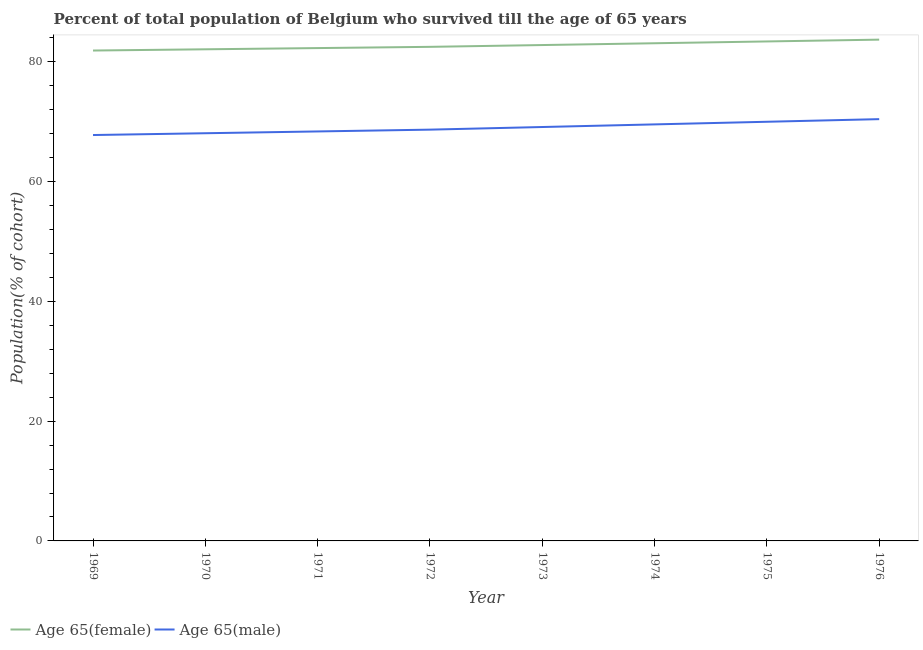How many different coloured lines are there?
Provide a short and direct response. 2. What is the percentage of male population who survived till age of 65 in 1971?
Keep it short and to the point. 68.39. Across all years, what is the maximum percentage of female population who survived till age of 65?
Offer a very short reply. 83.72. Across all years, what is the minimum percentage of male population who survived till age of 65?
Make the answer very short. 67.79. In which year was the percentage of male population who survived till age of 65 maximum?
Your answer should be very brief. 1976. In which year was the percentage of male population who survived till age of 65 minimum?
Offer a terse response. 1969. What is the total percentage of female population who survived till age of 65 in the graph?
Offer a very short reply. 661.88. What is the difference between the percentage of male population who survived till age of 65 in 1969 and that in 1976?
Your answer should be compact. -2.65. What is the difference between the percentage of male population who survived till age of 65 in 1969 and the percentage of female population who survived till age of 65 in 1970?
Your response must be concise. -14.32. What is the average percentage of female population who survived till age of 65 per year?
Provide a succinct answer. 82.74. In the year 1970, what is the difference between the percentage of male population who survived till age of 65 and percentage of female population who survived till age of 65?
Provide a short and direct response. -14.02. What is the ratio of the percentage of female population who survived till age of 65 in 1972 to that in 1974?
Your answer should be compact. 0.99. Is the difference between the percentage of male population who survived till age of 65 in 1969 and 1975 greater than the difference between the percentage of female population who survived till age of 65 in 1969 and 1975?
Ensure brevity in your answer.  No. What is the difference between the highest and the second highest percentage of female population who survived till age of 65?
Provide a succinct answer. 0.3. What is the difference between the highest and the lowest percentage of male population who survived till age of 65?
Provide a succinct answer. 2.65. Is the percentage of female population who survived till age of 65 strictly less than the percentage of male population who survived till age of 65 over the years?
Provide a short and direct response. No. How many years are there in the graph?
Your answer should be very brief. 8. Does the graph contain grids?
Keep it short and to the point. No. Where does the legend appear in the graph?
Offer a very short reply. Bottom left. How many legend labels are there?
Offer a very short reply. 2. What is the title of the graph?
Ensure brevity in your answer.  Percent of total population of Belgium who survived till the age of 65 years. What is the label or title of the Y-axis?
Ensure brevity in your answer.  Population(% of cohort). What is the Population(% of cohort) in Age 65(female) in 1969?
Ensure brevity in your answer.  81.9. What is the Population(% of cohort) of Age 65(male) in 1969?
Provide a succinct answer. 67.79. What is the Population(% of cohort) in Age 65(female) in 1970?
Offer a very short reply. 82.1. What is the Population(% of cohort) in Age 65(male) in 1970?
Your response must be concise. 68.09. What is the Population(% of cohort) in Age 65(female) in 1971?
Give a very brief answer. 82.31. What is the Population(% of cohort) in Age 65(male) in 1971?
Give a very brief answer. 68.39. What is the Population(% of cohort) of Age 65(female) in 1972?
Provide a short and direct response. 82.51. What is the Population(% of cohort) in Age 65(male) in 1972?
Provide a succinct answer. 68.69. What is the Population(% of cohort) of Age 65(female) in 1973?
Offer a terse response. 82.81. What is the Population(% of cohort) of Age 65(male) in 1973?
Give a very brief answer. 69.12. What is the Population(% of cohort) of Age 65(female) in 1974?
Make the answer very short. 83.11. What is the Population(% of cohort) in Age 65(male) in 1974?
Provide a succinct answer. 69.56. What is the Population(% of cohort) of Age 65(female) in 1975?
Make the answer very short. 83.42. What is the Population(% of cohort) of Age 65(male) in 1975?
Offer a very short reply. 70. What is the Population(% of cohort) of Age 65(female) in 1976?
Provide a short and direct response. 83.72. What is the Population(% of cohort) of Age 65(male) in 1976?
Offer a very short reply. 70.44. Across all years, what is the maximum Population(% of cohort) in Age 65(female)?
Make the answer very short. 83.72. Across all years, what is the maximum Population(% of cohort) of Age 65(male)?
Offer a very short reply. 70.44. Across all years, what is the minimum Population(% of cohort) of Age 65(female)?
Offer a very short reply. 81.9. Across all years, what is the minimum Population(% of cohort) of Age 65(male)?
Make the answer very short. 67.79. What is the total Population(% of cohort) in Age 65(female) in the graph?
Keep it short and to the point. 661.88. What is the total Population(% of cohort) in Age 65(male) in the graph?
Provide a succinct answer. 552.07. What is the difference between the Population(% of cohort) of Age 65(female) in 1969 and that in 1970?
Offer a very short reply. -0.2. What is the difference between the Population(% of cohort) of Age 65(male) in 1969 and that in 1970?
Provide a succinct answer. -0.3. What is the difference between the Population(% of cohort) in Age 65(female) in 1969 and that in 1971?
Make the answer very short. -0.41. What is the difference between the Population(% of cohort) of Age 65(male) in 1969 and that in 1971?
Give a very brief answer. -0.6. What is the difference between the Population(% of cohort) in Age 65(female) in 1969 and that in 1972?
Your answer should be very brief. -0.61. What is the difference between the Population(% of cohort) in Age 65(male) in 1969 and that in 1972?
Offer a very short reply. -0.9. What is the difference between the Population(% of cohort) of Age 65(female) in 1969 and that in 1973?
Offer a terse response. -0.92. What is the difference between the Population(% of cohort) in Age 65(male) in 1969 and that in 1973?
Give a very brief answer. -1.34. What is the difference between the Population(% of cohort) in Age 65(female) in 1969 and that in 1974?
Provide a short and direct response. -1.22. What is the difference between the Population(% of cohort) of Age 65(male) in 1969 and that in 1974?
Ensure brevity in your answer.  -1.78. What is the difference between the Population(% of cohort) in Age 65(female) in 1969 and that in 1975?
Make the answer very short. -1.52. What is the difference between the Population(% of cohort) of Age 65(male) in 1969 and that in 1975?
Give a very brief answer. -2.22. What is the difference between the Population(% of cohort) in Age 65(female) in 1969 and that in 1976?
Provide a succinct answer. -1.82. What is the difference between the Population(% of cohort) of Age 65(male) in 1969 and that in 1976?
Your answer should be compact. -2.65. What is the difference between the Population(% of cohort) of Age 65(female) in 1970 and that in 1971?
Your answer should be very brief. -0.2. What is the difference between the Population(% of cohort) in Age 65(male) in 1970 and that in 1971?
Give a very brief answer. -0.3. What is the difference between the Population(% of cohort) in Age 65(female) in 1970 and that in 1972?
Ensure brevity in your answer.  -0.41. What is the difference between the Population(% of cohort) in Age 65(male) in 1970 and that in 1972?
Keep it short and to the point. -0.6. What is the difference between the Population(% of cohort) of Age 65(female) in 1970 and that in 1973?
Your answer should be very brief. -0.71. What is the difference between the Population(% of cohort) of Age 65(male) in 1970 and that in 1973?
Provide a short and direct response. -1.04. What is the difference between the Population(% of cohort) in Age 65(female) in 1970 and that in 1974?
Your answer should be very brief. -1.01. What is the difference between the Population(% of cohort) of Age 65(male) in 1970 and that in 1974?
Make the answer very short. -1.48. What is the difference between the Population(% of cohort) in Age 65(female) in 1970 and that in 1975?
Make the answer very short. -1.31. What is the difference between the Population(% of cohort) of Age 65(male) in 1970 and that in 1975?
Provide a short and direct response. -1.91. What is the difference between the Population(% of cohort) in Age 65(female) in 1970 and that in 1976?
Your answer should be very brief. -1.61. What is the difference between the Population(% of cohort) of Age 65(male) in 1970 and that in 1976?
Ensure brevity in your answer.  -2.35. What is the difference between the Population(% of cohort) in Age 65(female) in 1971 and that in 1972?
Provide a succinct answer. -0.2. What is the difference between the Population(% of cohort) in Age 65(male) in 1971 and that in 1972?
Make the answer very short. -0.3. What is the difference between the Population(% of cohort) of Age 65(female) in 1971 and that in 1973?
Your response must be concise. -0.51. What is the difference between the Population(% of cohort) in Age 65(male) in 1971 and that in 1973?
Your answer should be very brief. -0.74. What is the difference between the Population(% of cohort) in Age 65(female) in 1971 and that in 1974?
Provide a succinct answer. -0.81. What is the difference between the Population(% of cohort) in Age 65(male) in 1971 and that in 1974?
Your response must be concise. -1.18. What is the difference between the Population(% of cohort) of Age 65(female) in 1971 and that in 1975?
Offer a very short reply. -1.11. What is the difference between the Population(% of cohort) in Age 65(male) in 1971 and that in 1975?
Keep it short and to the point. -1.61. What is the difference between the Population(% of cohort) in Age 65(female) in 1971 and that in 1976?
Give a very brief answer. -1.41. What is the difference between the Population(% of cohort) of Age 65(male) in 1971 and that in 1976?
Make the answer very short. -2.05. What is the difference between the Population(% of cohort) in Age 65(female) in 1972 and that in 1973?
Give a very brief answer. -0.3. What is the difference between the Population(% of cohort) of Age 65(male) in 1972 and that in 1973?
Your answer should be compact. -0.44. What is the difference between the Population(% of cohort) of Age 65(female) in 1972 and that in 1974?
Provide a short and direct response. -0.6. What is the difference between the Population(% of cohort) in Age 65(male) in 1972 and that in 1974?
Offer a terse response. -0.88. What is the difference between the Population(% of cohort) in Age 65(female) in 1972 and that in 1975?
Provide a succinct answer. -0.9. What is the difference between the Population(% of cohort) in Age 65(male) in 1972 and that in 1975?
Provide a succinct answer. -1.31. What is the difference between the Population(% of cohort) in Age 65(female) in 1972 and that in 1976?
Keep it short and to the point. -1.2. What is the difference between the Population(% of cohort) of Age 65(male) in 1972 and that in 1976?
Make the answer very short. -1.75. What is the difference between the Population(% of cohort) in Age 65(female) in 1973 and that in 1974?
Your answer should be compact. -0.3. What is the difference between the Population(% of cohort) of Age 65(male) in 1973 and that in 1974?
Your answer should be very brief. -0.44. What is the difference between the Population(% of cohort) in Age 65(female) in 1973 and that in 1975?
Offer a terse response. -0.6. What is the difference between the Population(% of cohort) in Age 65(male) in 1973 and that in 1975?
Provide a short and direct response. -0.88. What is the difference between the Population(% of cohort) in Age 65(female) in 1973 and that in 1976?
Give a very brief answer. -0.9. What is the difference between the Population(% of cohort) of Age 65(male) in 1973 and that in 1976?
Provide a succinct answer. -1.31. What is the difference between the Population(% of cohort) of Age 65(female) in 1974 and that in 1975?
Provide a succinct answer. -0.3. What is the difference between the Population(% of cohort) in Age 65(male) in 1974 and that in 1975?
Your response must be concise. -0.44. What is the difference between the Population(% of cohort) in Age 65(female) in 1974 and that in 1976?
Offer a very short reply. -0.6. What is the difference between the Population(% of cohort) of Age 65(male) in 1974 and that in 1976?
Offer a very short reply. -0.88. What is the difference between the Population(% of cohort) in Age 65(female) in 1975 and that in 1976?
Make the answer very short. -0.3. What is the difference between the Population(% of cohort) in Age 65(male) in 1975 and that in 1976?
Offer a terse response. -0.44. What is the difference between the Population(% of cohort) in Age 65(female) in 1969 and the Population(% of cohort) in Age 65(male) in 1970?
Offer a very short reply. 13.81. What is the difference between the Population(% of cohort) in Age 65(female) in 1969 and the Population(% of cohort) in Age 65(male) in 1971?
Offer a terse response. 13.51. What is the difference between the Population(% of cohort) of Age 65(female) in 1969 and the Population(% of cohort) of Age 65(male) in 1972?
Your answer should be very brief. 13.21. What is the difference between the Population(% of cohort) of Age 65(female) in 1969 and the Population(% of cohort) of Age 65(male) in 1973?
Provide a short and direct response. 12.77. What is the difference between the Population(% of cohort) of Age 65(female) in 1969 and the Population(% of cohort) of Age 65(male) in 1974?
Offer a very short reply. 12.34. What is the difference between the Population(% of cohort) of Age 65(female) in 1969 and the Population(% of cohort) of Age 65(male) in 1975?
Offer a very short reply. 11.9. What is the difference between the Population(% of cohort) of Age 65(female) in 1969 and the Population(% of cohort) of Age 65(male) in 1976?
Your answer should be compact. 11.46. What is the difference between the Population(% of cohort) in Age 65(female) in 1970 and the Population(% of cohort) in Age 65(male) in 1971?
Offer a terse response. 13.72. What is the difference between the Population(% of cohort) in Age 65(female) in 1970 and the Population(% of cohort) in Age 65(male) in 1972?
Your answer should be very brief. 13.42. What is the difference between the Population(% of cohort) in Age 65(female) in 1970 and the Population(% of cohort) in Age 65(male) in 1973?
Offer a very short reply. 12.98. What is the difference between the Population(% of cohort) in Age 65(female) in 1970 and the Population(% of cohort) in Age 65(male) in 1974?
Offer a very short reply. 12.54. What is the difference between the Population(% of cohort) in Age 65(female) in 1970 and the Population(% of cohort) in Age 65(male) in 1975?
Give a very brief answer. 12.1. What is the difference between the Population(% of cohort) in Age 65(female) in 1970 and the Population(% of cohort) in Age 65(male) in 1976?
Your answer should be very brief. 11.66. What is the difference between the Population(% of cohort) in Age 65(female) in 1971 and the Population(% of cohort) in Age 65(male) in 1972?
Keep it short and to the point. 13.62. What is the difference between the Population(% of cohort) of Age 65(female) in 1971 and the Population(% of cohort) of Age 65(male) in 1973?
Provide a succinct answer. 13.18. What is the difference between the Population(% of cohort) of Age 65(female) in 1971 and the Population(% of cohort) of Age 65(male) in 1974?
Provide a succinct answer. 12.75. What is the difference between the Population(% of cohort) of Age 65(female) in 1971 and the Population(% of cohort) of Age 65(male) in 1975?
Ensure brevity in your answer.  12.31. What is the difference between the Population(% of cohort) in Age 65(female) in 1971 and the Population(% of cohort) in Age 65(male) in 1976?
Make the answer very short. 11.87. What is the difference between the Population(% of cohort) of Age 65(female) in 1972 and the Population(% of cohort) of Age 65(male) in 1973?
Give a very brief answer. 13.39. What is the difference between the Population(% of cohort) in Age 65(female) in 1972 and the Population(% of cohort) in Age 65(male) in 1974?
Provide a short and direct response. 12.95. What is the difference between the Population(% of cohort) in Age 65(female) in 1972 and the Population(% of cohort) in Age 65(male) in 1975?
Make the answer very short. 12.51. What is the difference between the Population(% of cohort) of Age 65(female) in 1972 and the Population(% of cohort) of Age 65(male) in 1976?
Offer a very short reply. 12.07. What is the difference between the Population(% of cohort) of Age 65(female) in 1973 and the Population(% of cohort) of Age 65(male) in 1974?
Offer a very short reply. 13.25. What is the difference between the Population(% of cohort) in Age 65(female) in 1973 and the Population(% of cohort) in Age 65(male) in 1975?
Ensure brevity in your answer.  12.81. What is the difference between the Population(% of cohort) of Age 65(female) in 1973 and the Population(% of cohort) of Age 65(male) in 1976?
Offer a very short reply. 12.38. What is the difference between the Population(% of cohort) of Age 65(female) in 1974 and the Population(% of cohort) of Age 65(male) in 1975?
Your answer should be compact. 13.11. What is the difference between the Population(% of cohort) in Age 65(female) in 1974 and the Population(% of cohort) in Age 65(male) in 1976?
Offer a very short reply. 12.68. What is the difference between the Population(% of cohort) in Age 65(female) in 1975 and the Population(% of cohort) in Age 65(male) in 1976?
Make the answer very short. 12.98. What is the average Population(% of cohort) in Age 65(female) per year?
Offer a terse response. 82.74. What is the average Population(% of cohort) of Age 65(male) per year?
Your answer should be very brief. 69.01. In the year 1969, what is the difference between the Population(% of cohort) of Age 65(female) and Population(% of cohort) of Age 65(male)?
Give a very brief answer. 14.11. In the year 1970, what is the difference between the Population(% of cohort) of Age 65(female) and Population(% of cohort) of Age 65(male)?
Make the answer very short. 14.02. In the year 1971, what is the difference between the Population(% of cohort) in Age 65(female) and Population(% of cohort) in Age 65(male)?
Provide a succinct answer. 13.92. In the year 1972, what is the difference between the Population(% of cohort) of Age 65(female) and Population(% of cohort) of Age 65(male)?
Keep it short and to the point. 13.83. In the year 1973, what is the difference between the Population(% of cohort) in Age 65(female) and Population(% of cohort) in Age 65(male)?
Provide a succinct answer. 13.69. In the year 1974, what is the difference between the Population(% of cohort) in Age 65(female) and Population(% of cohort) in Age 65(male)?
Keep it short and to the point. 13.55. In the year 1975, what is the difference between the Population(% of cohort) in Age 65(female) and Population(% of cohort) in Age 65(male)?
Provide a short and direct response. 13.41. In the year 1976, what is the difference between the Population(% of cohort) in Age 65(female) and Population(% of cohort) in Age 65(male)?
Keep it short and to the point. 13.28. What is the ratio of the Population(% of cohort) in Age 65(female) in 1969 to that in 1970?
Make the answer very short. 1. What is the ratio of the Population(% of cohort) of Age 65(male) in 1969 to that in 1970?
Your answer should be compact. 1. What is the ratio of the Population(% of cohort) in Age 65(female) in 1969 to that in 1971?
Offer a very short reply. 0.99. What is the ratio of the Population(% of cohort) in Age 65(female) in 1969 to that in 1972?
Keep it short and to the point. 0.99. What is the ratio of the Population(% of cohort) of Age 65(male) in 1969 to that in 1972?
Your response must be concise. 0.99. What is the ratio of the Population(% of cohort) in Age 65(female) in 1969 to that in 1973?
Keep it short and to the point. 0.99. What is the ratio of the Population(% of cohort) in Age 65(male) in 1969 to that in 1973?
Provide a short and direct response. 0.98. What is the ratio of the Population(% of cohort) in Age 65(female) in 1969 to that in 1974?
Your response must be concise. 0.99. What is the ratio of the Population(% of cohort) of Age 65(male) in 1969 to that in 1974?
Your response must be concise. 0.97. What is the ratio of the Population(% of cohort) of Age 65(female) in 1969 to that in 1975?
Make the answer very short. 0.98. What is the ratio of the Population(% of cohort) of Age 65(male) in 1969 to that in 1975?
Give a very brief answer. 0.97. What is the ratio of the Population(% of cohort) of Age 65(female) in 1969 to that in 1976?
Offer a terse response. 0.98. What is the ratio of the Population(% of cohort) of Age 65(male) in 1969 to that in 1976?
Your answer should be very brief. 0.96. What is the ratio of the Population(% of cohort) in Age 65(male) in 1970 to that in 1971?
Offer a very short reply. 1. What is the ratio of the Population(% of cohort) in Age 65(female) in 1970 to that in 1972?
Provide a short and direct response. 0.99. What is the ratio of the Population(% of cohort) of Age 65(male) in 1970 to that in 1972?
Provide a succinct answer. 0.99. What is the ratio of the Population(% of cohort) of Age 65(female) in 1970 to that in 1973?
Provide a succinct answer. 0.99. What is the ratio of the Population(% of cohort) of Age 65(male) in 1970 to that in 1973?
Make the answer very short. 0.98. What is the ratio of the Population(% of cohort) in Age 65(female) in 1970 to that in 1974?
Provide a short and direct response. 0.99. What is the ratio of the Population(% of cohort) in Age 65(male) in 1970 to that in 1974?
Make the answer very short. 0.98. What is the ratio of the Population(% of cohort) in Age 65(female) in 1970 to that in 1975?
Give a very brief answer. 0.98. What is the ratio of the Population(% of cohort) in Age 65(male) in 1970 to that in 1975?
Your answer should be very brief. 0.97. What is the ratio of the Population(% of cohort) of Age 65(female) in 1970 to that in 1976?
Offer a terse response. 0.98. What is the ratio of the Population(% of cohort) of Age 65(male) in 1970 to that in 1976?
Offer a very short reply. 0.97. What is the ratio of the Population(% of cohort) of Age 65(female) in 1971 to that in 1972?
Keep it short and to the point. 1. What is the ratio of the Population(% of cohort) in Age 65(male) in 1971 to that in 1973?
Provide a succinct answer. 0.99. What is the ratio of the Population(% of cohort) of Age 65(female) in 1971 to that in 1974?
Offer a terse response. 0.99. What is the ratio of the Population(% of cohort) of Age 65(male) in 1971 to that in 1974?
Provide a short and direct response. 0.98. What is the ratio of the Population(% of cohort) of Age 65(female) in 1971 to that in 1975?
Your answer should be very brief. 0.99. What is the ratio of the Population(% of cohort) of Age 65(male) in 1971 to that in 1975?
Offer a terse response. 0.98. What is the ratio of the Population(% of cohort) in Age 65(female) in 1971 to that in 1976?
Keep it short and to the point. 0.98. What is the ratio of the Population(% of cohort) of Age 65(male) in 1971 to that in 1976?
Offer a very short reply. 0.97. What is the ratio of the Population(% of cohort) in Age 65(female) in 1972 to that in 1973?
Offer a very short reply. 1. What is the ratio of the Population(% of cohort) in Age 65(male) in 1972 to that in 1973?
Provide a short and direct response. 0.99. What is the ratio of the Population(% of cohort) of Age 65(male) in 1972 to that in 1974?
Offer a terse response. 0.99. What is the ratio of the Population(% of cohort) of Age 65(male) in 1972 to that in 1975?
Your response must be concise. 0.98. What is the ratio of the Population(% of cohort) of Age 65(female) in 1972 to that in 1976?
Offer a terse response. 0.99. What is the ratio of the Population(% of cohort) of Age 65(male) in 1972 to that in 1976?
Give a very brief answer. 0.98. What is the ratio of the Population(% of cohort) in Age 65(male) in 1973 to that in 1974?
Your response must be concise. 0.99. What is the ratio of the Population(% of cohort) in Age 65(female) in 1973 to that in 1975?
Provide a short and direct response. 0.99. What is the ratio of the Population(% of cohort) of Age 65(male) in 1973 to that in 1975?
Your answer should be compact. 0.99. What is the ratio of the Population(% of cohort) in Age 65(female) in 1973 to that in 1976?
Offer a very short reply. 0.99. What is the ratio of the Population(% of cohort) of Age 65(male) in 1973 to that in 1976?
Ensure brevity in your answer.  0.98. What is the ratio of the Population(% of cohort) of Age 65(female) in 1974 to that in 1976?
Your answer should be very brief. 0.99. What is the ratio of the Population(% of cohort) in Age 65(male) in 1974 to that in 1976?
Your answer should be very brief. 0.99. What is the ratio of the Population(% of cohort) in Age 65(female) in 1975 to that in 1976?
Provide a succinct answer. 1. What is the difference between the highest and the second highest Population(% of cohort) in Age 65(female)?
Your response must be concise. 0.3. What is the difference between the highest and the second highest Population(% of cohort) of Age 65(male)?
Give a very brief answer. 0.44. What is the difference between the highest and the lowest Population(% of cohort) in Age 65(female)?
Ensure brevity in your answer.  1.82. What is the difference between the highest and the lowest Population(% of cohort) in Age 65(male)?
Your answer should be very brief. 2.65. 